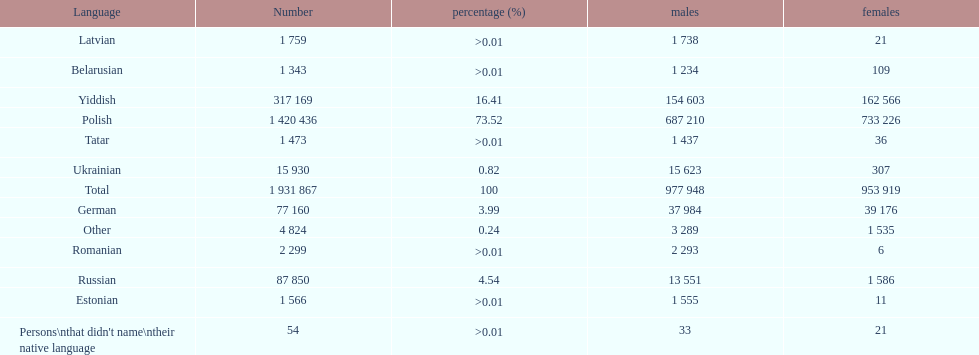What was the next most commonly spoken language in poland after russian? German. 